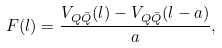<formula> <loc_0><loc_0><loc_500><loc_500>F ( l ) = \frac { V _ { Q \bar { Q } } ( l ) - V _ { Q \bar { Q } } ( l - a ) } { a } ,</formula> 